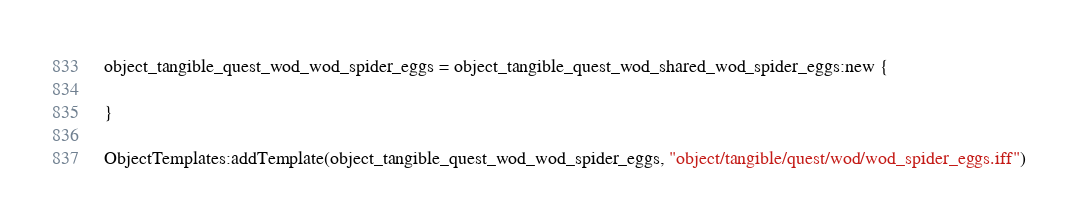<code> <loc_0><loc_0><loc_500><loc_500><_Lua_>object_tangible_quest_wod_wod_spider_eggs = object_tangible_quest_wod_shared_wod_spider_eggs:new {

}

ObjectTemplates:addTemplate(object_tangible_quest_wod_wod_spider_eggs, "object/tangible/quest/wod/wod_spider_eggs.iff")
</code> 